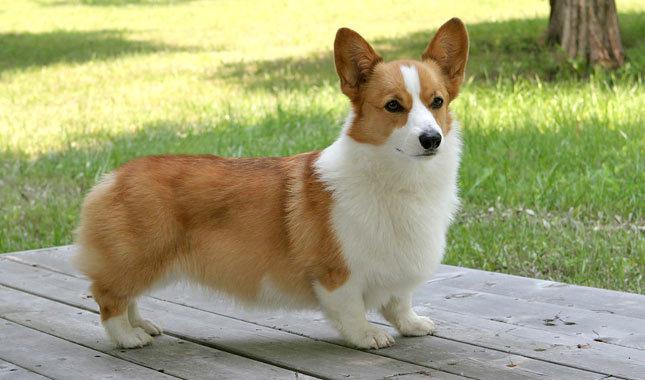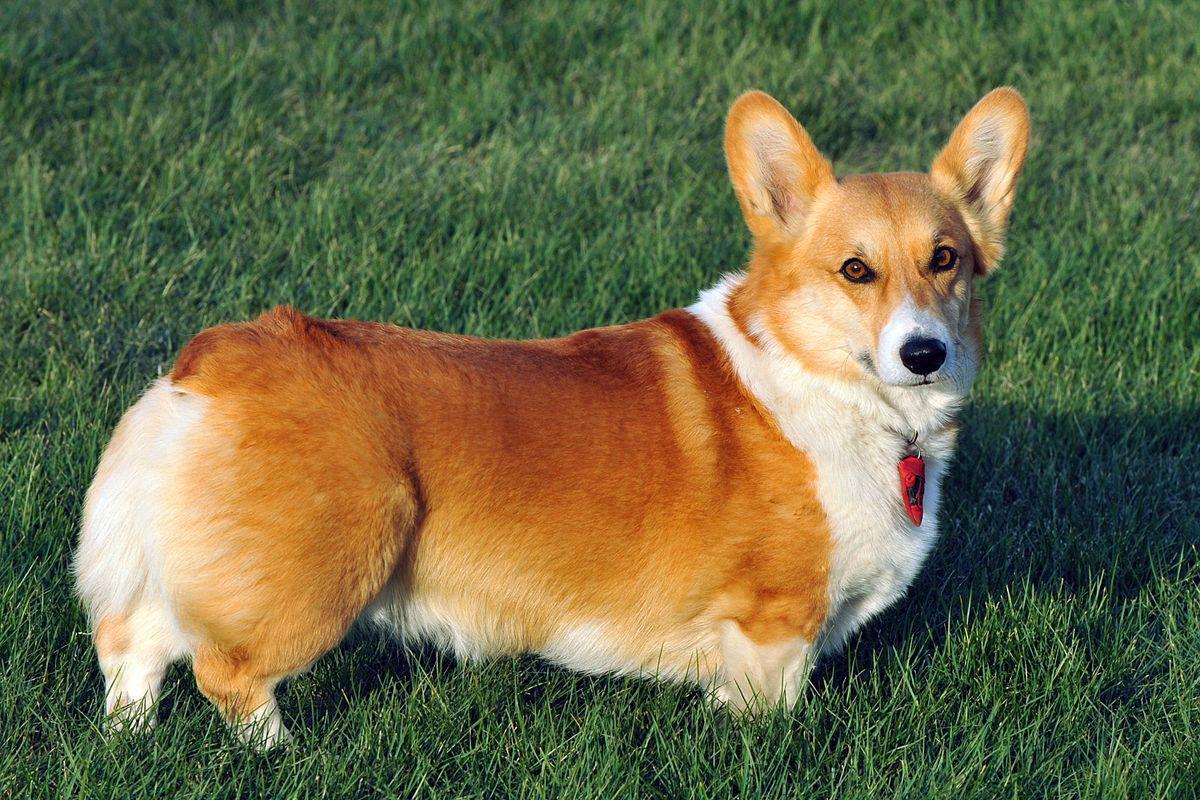The first image is the image on the left, the second image is the image on the right. Given the left and right images, does the statement "A dog is walking on grass with one paw up." hold true? Answer yes or no. No. The first image is the image on the left, the second image is the image on the right. Assess this claim about the two images: "the dog in the image on the left is in side profile". Correct or not? Answer yes or no. Yes. 